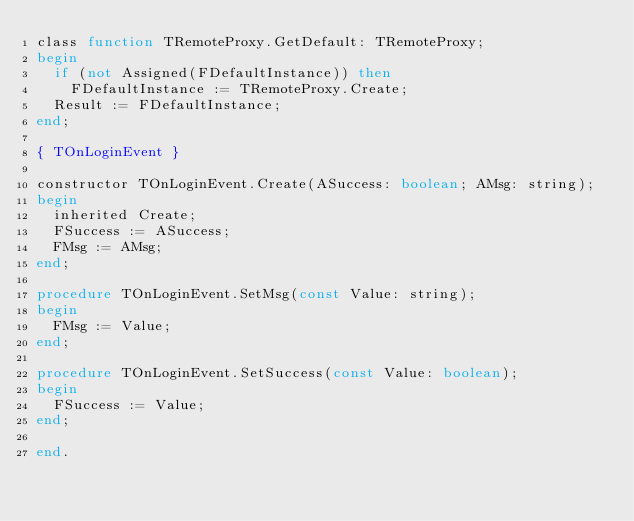<code> <loc_0><loc_0><loc_500><loc_500><_Pascal_>class function TRemoteProxy.GetDefault: TRemoteProxy;
begin
  if (not Assigned(FDefaultInstance)) then
    FDefaultInstance := TRemoteProxy.Create;
  Result := FDefaultInstance;
end;

{ TOnLoginEvent }

constructor TOnLoginEvent.Create(ASuccess: boolean; AMsg: string);
begin
  inherited Create;
  FSuccess := ASuccess;
  FMsg := AMsg;
end;

procedure TOnLoginEvent.SetMsg(const Value: string);
begin
  FMsg := Value;
end;

procedure TOnLoginEvent.SetSuccess(const Value: boolean);
begin
  FSuccess := Value;
end;

end.
</code> 